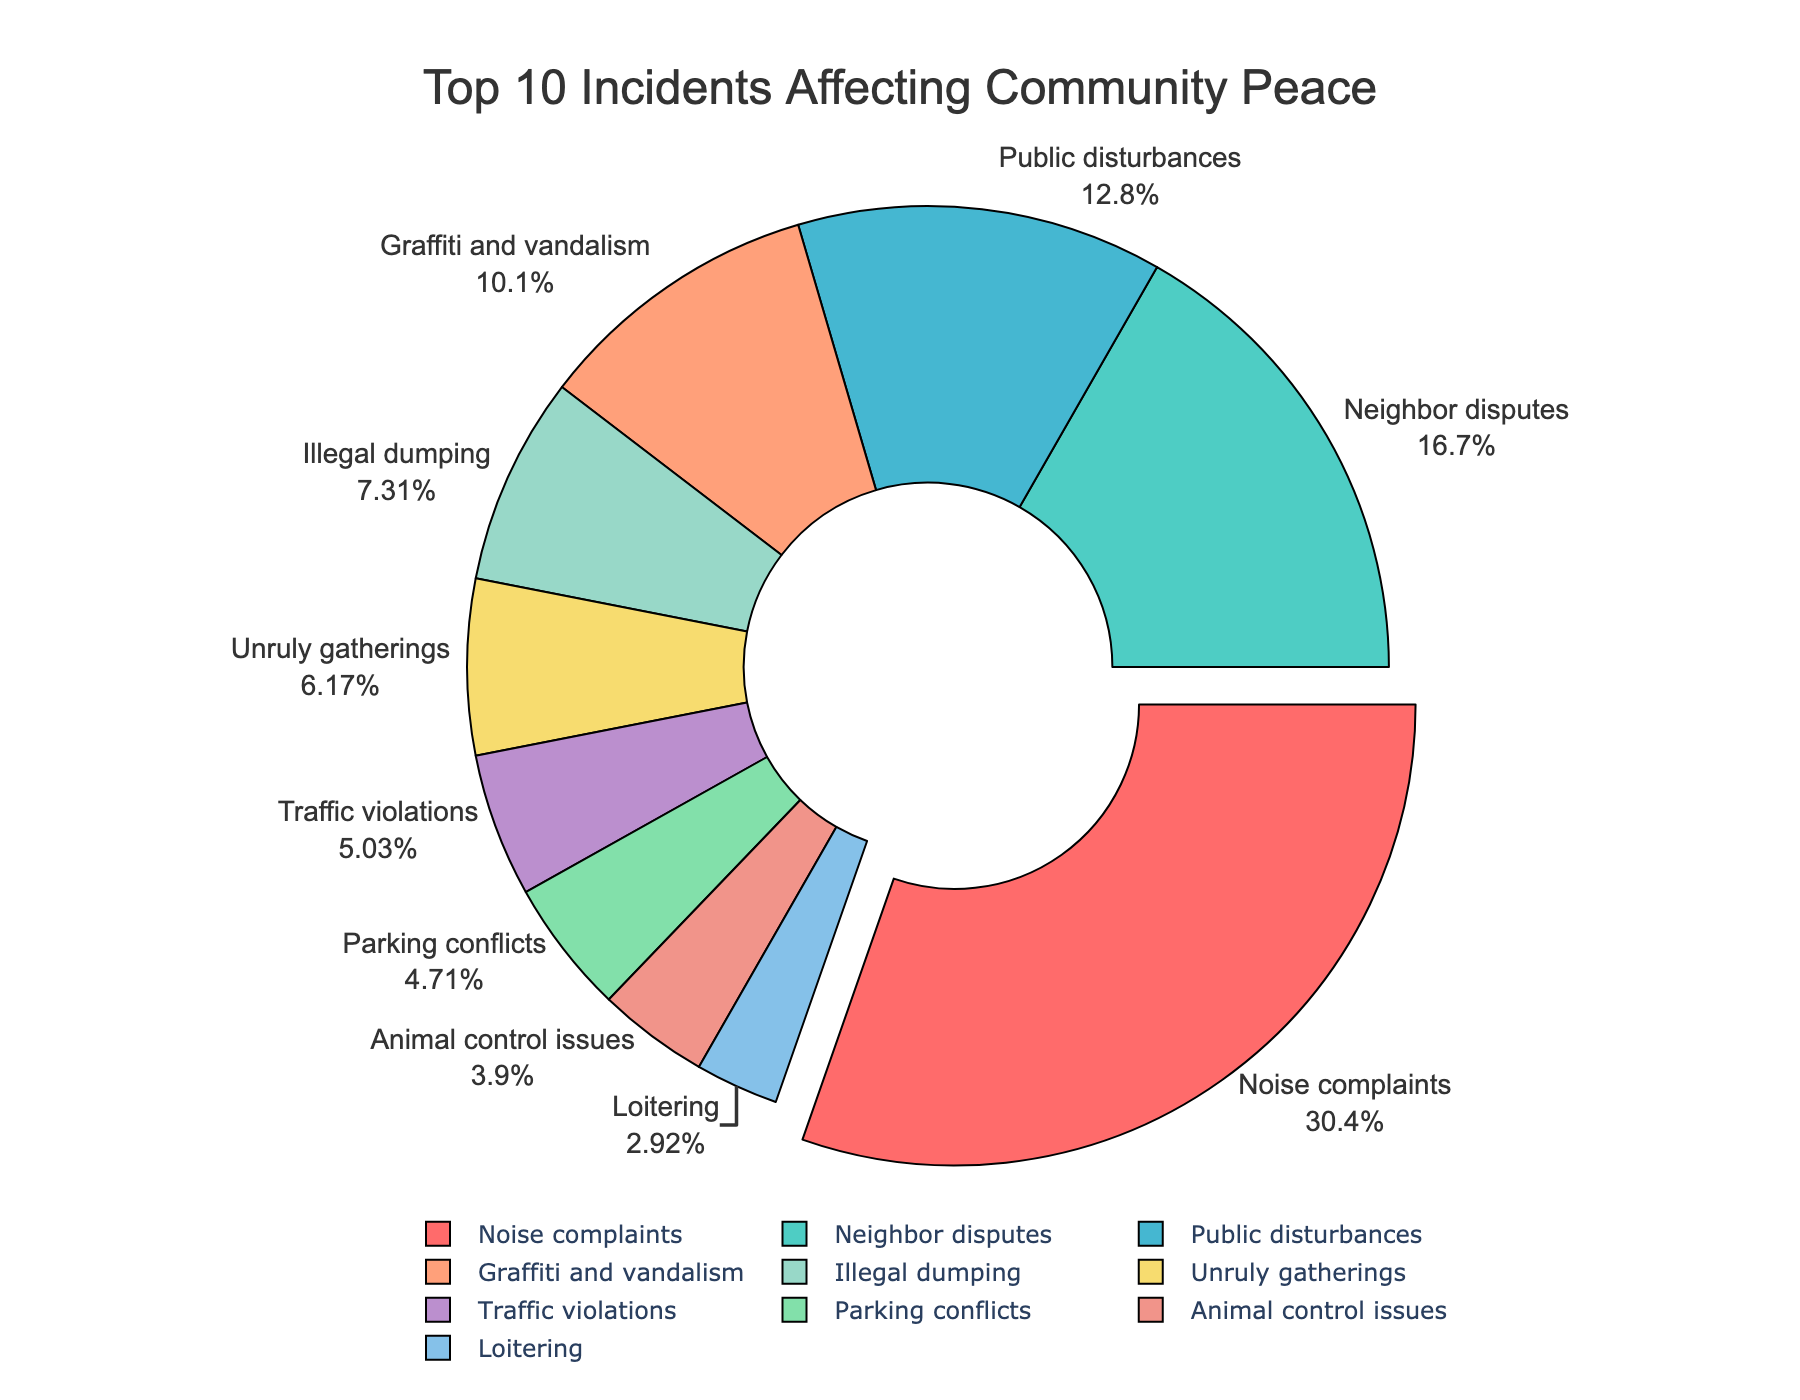What percentage of reported incidents are noise complaints? Noise complaints are represented by the slice pulled out of the pie chart. The label on this slice shows both the category name and the percentage.
Answer: 23.5% Which category has the least number of incidents within the top 10? By looking at the pie chart, the smallest slice (excluding categories outside the top 10) will represent the category with the least incidents among the top 10.
Answer: Loitering How do the incidents of illegal dumping compare to unruly gatherings? Find the slices labeled "Illegal dumping" and "Unruly gatherings" and compare their sizes and percentages. Illegal dumping has a slightly larger slice and thus more incidents.
Answer: Illegal dumping has more incidents than unruly gatherings What is the combined percentage of noise complaints and neighbor disputes? Sum the percentages of noise complaints and neighbor disputes from their respective slices in the pie chart.
Answer: 23.5% + 12.9% = 36.4% Which categories together make up almost half of the reported incidents? Look for slices that sum up to about 50%. Noise complaints (23.5%) and neighbor disputes (12.9%) together make up 36.4%, and adding public disturbances (9.9%) gets close to half.
Answer: Noise complaints, neighbor disputes, and public disturbances How many more incidents are there in graffiti and vandalism compared to animal control issues? Find the slices for both categories and note that graffiti and vandalism have more incidents. Subtract the number of incidents in animal control issues from graffiti and vandalism.
Answer: 62 - 24 = 38 Which color represents the most frequently reported incident category? Observe the color that corresponds to the largest slice, which is noise complaints.
Answer: Red What percentage of incidents are caused by the combination of public disturbances and graffiti and vandalism? Sum the percentages of public disturbances and graffiti and vandalism.
Answer: 9.9% + 7.8% = 17.7% How does the size of the slice for parking conflicts compare with that of traffic violations? Check the slices for both categories and compare their sizes. Parking conflicts have a smaller slice than traffic violations.
Answer: Parking conflicts < Traffic violations Which slice has a similar size to illegal dumping, and what is its percentage? Locate the slice for illegal dumping and find another slice of a similar size. Unruly gatherings have a comparable slice. Check the percentage on the similar slice.
Answer: Unruly gatherings, 4.8% 